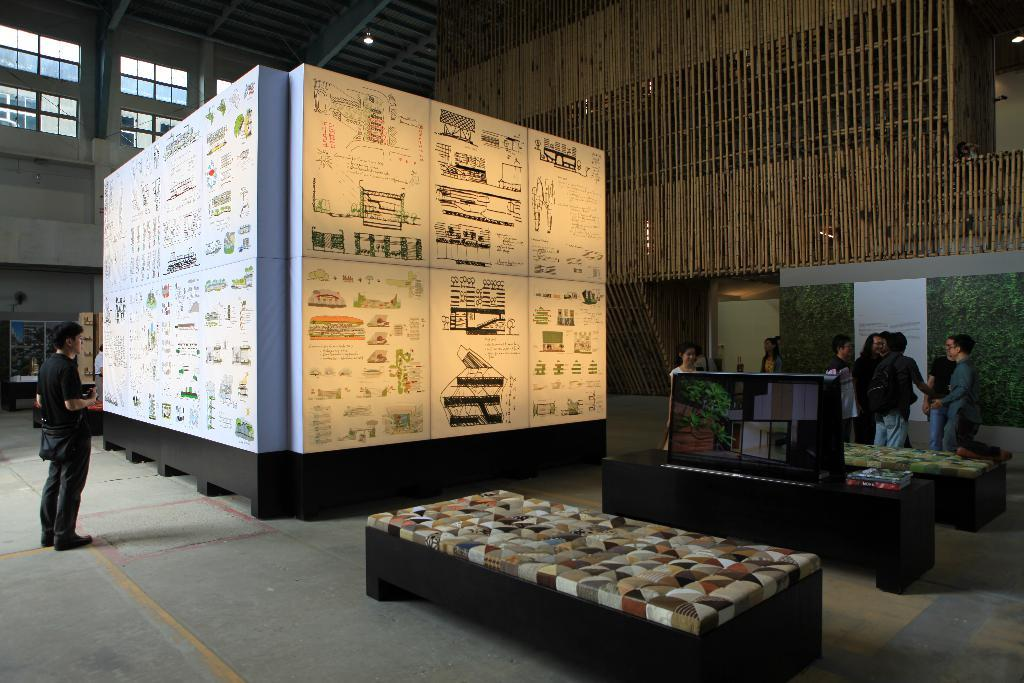What can be seen in the image? There are people standing in the image. What else is present in the image besides the people? There is a big box in the image. Can you see any bees buzzing around the people in the image? There are no bees visible in the image. Is there any sand present in the image? There is no sand present in the image. 